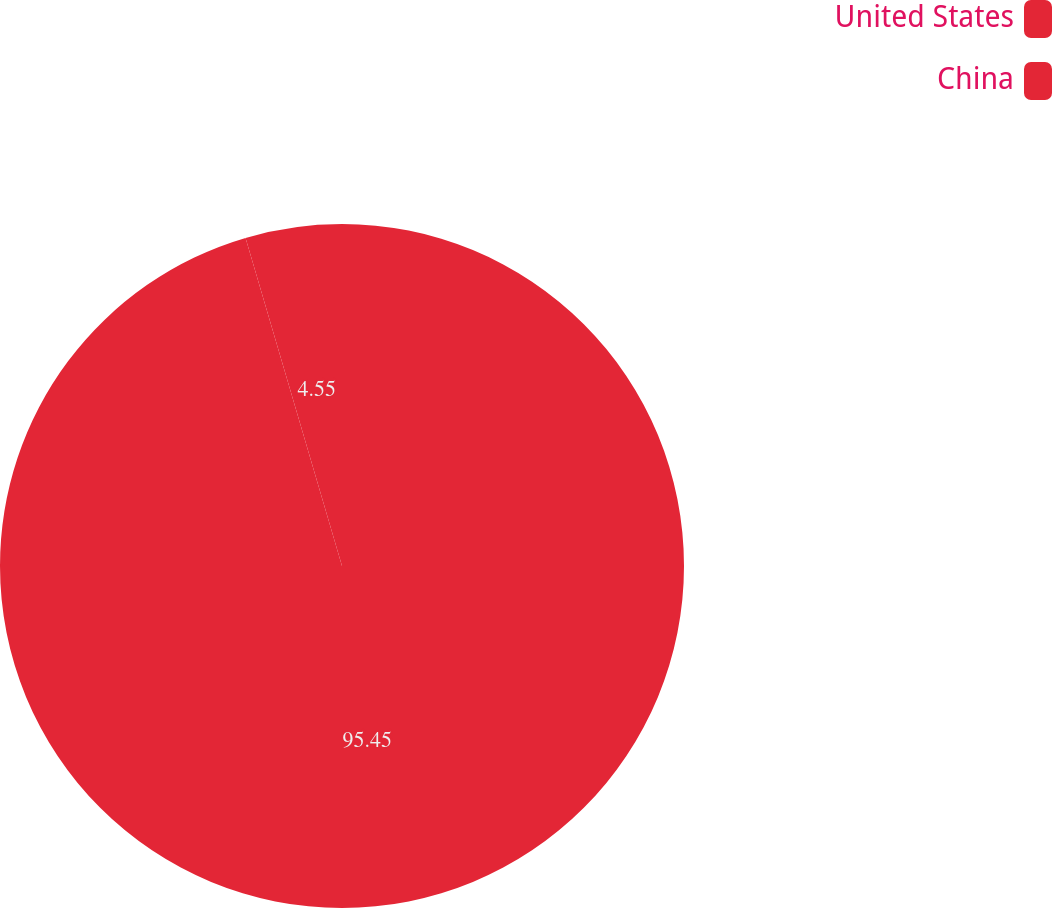<chart> <loc_0><loc_0><loc_500><loc_500><pie_chart><fcel>United States<fcel>China<nl><fcel>95.45%<fcel>4.55%<nl></chart> 